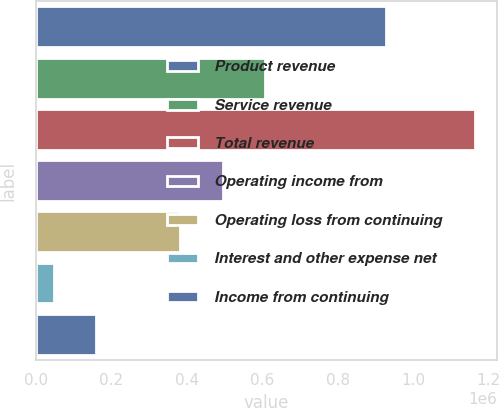Convert chart. <chart><loc_0><loc_0><loc_500><loc_500><bar_chart><fcel>Product revenue<fcel>Service revenue<fcel>Total revenue<fcel>Operating income from<fcel>Operating loss from continuing<fcel>Interest and other expense net<fcel>Income from continuing<nl><fcel>926733<fcel>606290<fcel>1.16462e+06<fcel>494624<fcel>382957<fcel>47956<fcel>159623<nl></chart> 